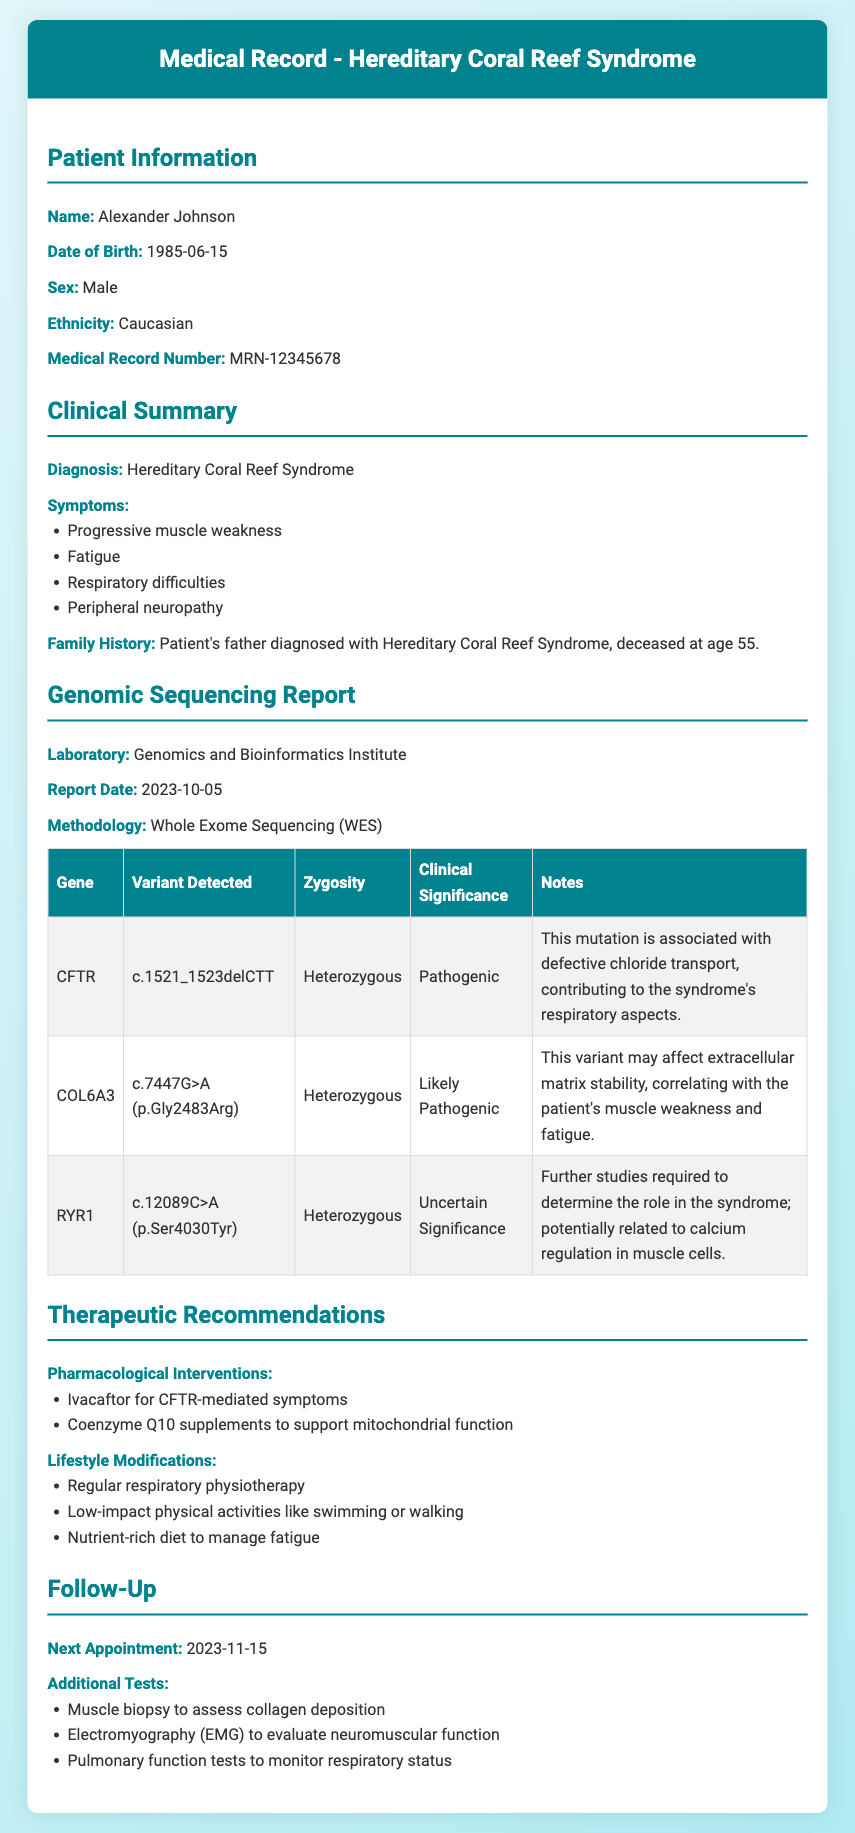What is the patient's name? The patient's name is listed at the beginning of the document under Patient Information.
Answer: Alexander Johnson What is the report date? The report date can be found in the Genomic Sequencing Report section of the document.
Answer: 2023-10-05 What is the methodology used for the genomic sequencing? The methodology is provided in the Genomic Sequencing Report section.
Answer: Whole Exome Sequencing (WES) What gene is associated with a pathogenic variant related to respiratory aspects? This information is found in the details about the CFTR gene in the Genomic Sequencing Report.
Answer: CFTR Which symptom is likely correlated with the COL6A3 variant? The symptom is derived from the notes on the COL6A3 variant regarding its effects.
Answer: Muscle weakness and fatigue How many pharmacological interventions are recommended? This can be calculated by counting the items listed under Pharmacological Interventions in the Therapeutic Recommendations section.
Answer: 2 What is the next appointment date? The date of the next appointment is mentioned in the Follow-Up section.
Answer: 2023-11-15 What kind of tests are recommended for additional evaluation? The types of tests can be found in the Additional Tests list under the Follow-Up section.
Answer: Muscle biopsy, Electromyography (EMG), Pulmonary function tests What is the clinical significance of the RYR1 variant? The clinical significance is mentioned in the Genomic Sequencing Report section for the RYR1 gene.
Answer: Uncertain Significance 